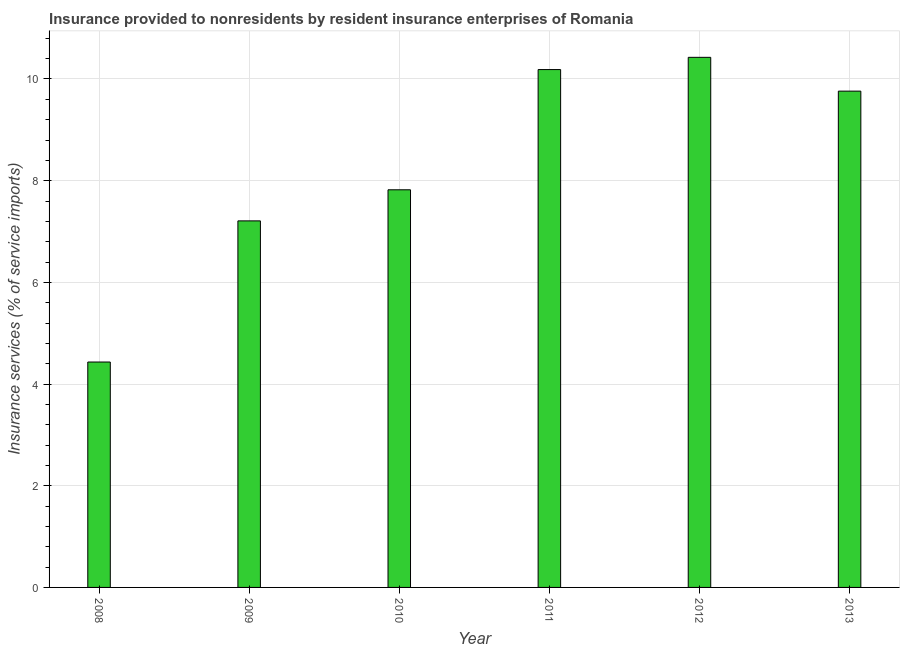Does the graph contain grids?
Offer a very short reply. Yes. What is the title of the graph?
Your response must be concise. Insurance provided to nonresidents by resident insurance enterprises of Romania. What is the label or title of the X-axis?
Ensure brevity in your answer.  Year. What is the label or title of the Y-axis?
Your answer should be compact. Insurance services (% of service imports). What is the insurance and financial services in 2012?
Provide a succinct answer. 10.43. Across all years, what is the maximum insurance and financial services?
Your answer should be very brief. 10.43. Across all years, what is the minimum insurance and financial services?
Provide a short and direct response. 4.43. In which year was the insurance and financial services maximum?
Your answer should be very brief. 2012. In which year was the insurance and financial services minimum?
Offer a terse response. 2008. What is the sum of the insurance and financial services?
Ensure brevity in your answer.  49.84. What is the difference between the insurance and financial services in 2009 and 2011?
Offer a very short reply. -2.98. What is the average insurance and financial services per year?
Your answer should be very brief. 8.31. What is the median insurance and financial services?
Provide a short and direct response. 8.79. What is the ratio of the insurance and financial services in 2008 to that in 2012?
Provide a succinct answer. 0.42. Is the insurance and financial services in 2008 less than that in 2012?
Make the answer very short. Yes. What is the difference between the highest and the second highest insurance and financial services?
Give a very brief answer. 0.24. Is the sum of the insurance and financial services in 2010 and 2013 greater than the maximum insurance and financial services across all years?
Give a very brief answer. Yes. What is the difference between the highest and the lowest insurance and financial services?
Provide a short and direct response. 5.99. In how many years, is the insurance and financial services greater than the average insurance and financial services taken over all years?
Make the answer very short. 3. How many bars are there?
Ensure brevity in your answer.  6. Are all the bars in the graph horizontal?
Ensure brevity in your answer.  No. How many years are there in the graph?
Provide a short and direct response. 6. What is the difference between two consecutive major ticks on the Y-axis?
Give a very brief answer. 2. What is the Insurance services (% of service imports) in 2008?
Make the answer very short. 4.43. What is the Insurance services (% of service imports) in 2009?
Keep it short and to the point. 7.21. What is the Insurance services (% of service imports) of 2010?
Make the answer very short. 7.82. What is the Insurance services (% of service imports) in 2011?
Your answer should be very brief. 10.19. What is the Insurance services (% of service imports) of 2012?
Provide a succinct answer. 10.43. What is the Insurance services (% of service imports) in 2013?
Give a very brief answer. 9.76. What is the difference between the Insurance services (% of service imports) in 2008 and 2009?
Provide a succinct answer. -2.78. What is the difference between the Insurance services (% of service imports) in 2008 and 2010?
Your answer should be compact. -3.39. What is the difference between the Insurance services (% of service imports) in 2008 and 2011?
Provide a succinct answer. -5.75. What is the difference between the Insurance services (% of service imports) in 2008 and 2012?
Provide a succinct answer. -5.99. What is the difference between the Insurance services (% of service imports) in 2008 and 2013?
Offer a terse response. -5.33. What is the difference between the Insurance services (% of service imports) in 2009 and 2010?
Keep it short and to the point. -0.61. What is the difference between the Insurance services (% of service imports) in 2009 and 2011?
Make the answer very short. -2.98. What is the difference between the Insurance services (% of service imports) in 2009 and 2012?
Provide a short and direct response. -3.22. What is the difference between the Insurance services (% of service imports) in 2009 and 2013?
Your response must be concise. -2.55. What is the difference between the Insurance services (% of service imports) in 2010 and 2011?
Your response must be concise. -2.36. What is the difference between the Insurance services (% of service imports) in 2010 and 2012?
Provide a succinct answer. -2.61. What is the difference between the Insurance services (% of service imports) in 2010 and 2013?
Provide a succinct answer. -1.94. What is the difference between the Insurance services (% of service imports) in 2011 and 2012?
Your response must be concise. -0.24. What is the difference between the Insurance services (% of service imports) in 2011 and 2013?
Offer a terse response. 0.42. What is the difference between the Insurance services (% of service imports) in 2012 and 2013?
Ensure brevity in your answer.  0.66. What is the ratio of the Insurance services (% of service imports) in 2008 to that in 2009?
Ensure brevity in your answer.  0.61. What is the ratio of the Insurance services (% of service imports) in 2008 to that in 2010?
Keep it short and to the point. 0.57. What is the ratio of the Insurance services (% of service imports) in 2008 to that in 2011?
Keep it short and to the point. 0.43. What is the ratio of the Insurance services (% of service imports) in 2008 to that in 2012?
Ensure brevity in your answer.  0.42. What is the ratio of the Insurance services (% of service imports) in 2008 to that in 2013?
Provide a succinct answer. 0.45. What is the ratio of the Insurance services (% of service imports) in 2009 to that in 2010?
Make the answer very short. 0.92. What is the ratio of the Insurance services (% of service imports) in 2009 to that in 2011?
Ensure brevity in your answer.  0.71. What is the ratio of the Insurance services (% of service imports) in 2009 to that in 2012?
Make the answer very short. 0.69. What is the ratio of the Insurance services (% of service imports) in 2009 to that in 2013?
Keep it short and to the point. 0.74. What is the ratio of the Insurance services (% of service imports) in 2010 to that in 2011?
Your answer should be very brief. 0.77. What is the ratio of the Insurance services (% of service imports) in 2010 to that in 2012?
Provide a short and direct response. 0.75. What is the ratio of the Insurance services (% of service imports) in 2010 to that in 2013?
Offer a terse response. 0.8. What is the ratio of the Insurance services (% of service imports) in 2011 to that in 2012?
Your answer should be very brief. 0.98. What is the ratio of the Insurance services (% of service imports) in 2011 to that in 2013?
Ensure brevity in your answer.  1.04. What is the ratio of the Insurance services (% of service imports) in 2012 to that in 2013?
Provide a succinct answer. 1.07. 